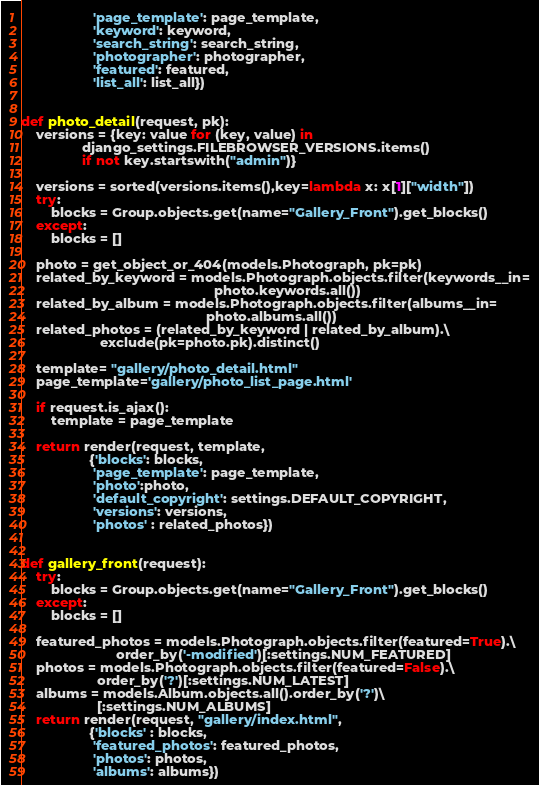Convert code to text. <code><loc_0><loc_0><loc_500><loc_500><_Python_>                   'page_template': page_template,
                   'keyword': keyword,
                   'search_string': search_string,
                   'photographer': photographer,
                   'featured': featured,
                   'list_all': list_all})


def photo_detail(request, pk):
    versions = {key: value for (key, value) in
                django_settings.FILEBROWSER_VERSIONS.items()
                if not key.startswith("admin")}

    versions = sorted(versions.items(),key=lambda x: x[1]["width"])
    try:
        blocks = Group.objects.get(name="Gallery_Front").get_blocks()
    except:
        blocks = []

    photo = get_object_or_404(models.Photograph, pk=pk)
    related_by_keyword = models.Photograph.objects.filter(keywords__in=
                                                   photo.keywords.all())
    related_by_album = models.Photograph.objects.filter(albums__in=
                                                 photo.albums.all())
    related_photos = (related_by_keyword | related_by_album).\
                     exclude(pk=photo.pk).distinct()

    template= "gallery/photo_detail.html"
    page_template='gallery/photo_list_page.html'

    if request.is_ajax():
        template = page_template

    return render(request, template,
                  {'blocks': blocks,
                   'page_template': page_template,
                   'photo':photo,
                   'default_copyright': settings.DEFAULT_COPYRIGHT,
                   'versions': versions,
                   'photos' : related_photos})


def gallery_front(request):
    try:
        blocks = Group.objects.get(name="Gallery_Front").get_blocks()
    except:
        blocks = []

    featured_photos = models.Photograph.objects.filter(featured=True).\
                         order_by('-modified')[:settings.NUM_FEATURED]
    photos = models.Photograph.objects.filter(featured=False).\
                    order_by('?')[:settings.NUM_LATEST]
    albums = models.Album.objects.all().order_by('?')\
                    [:settings.NUM_ALBUMS]
    return render(request, "gallery/index.html",
                  {'blocks' : blocks,
                   'featured_photos': featured_photos,
                   'photos': photos,
                   'albums': albums})
</code> 